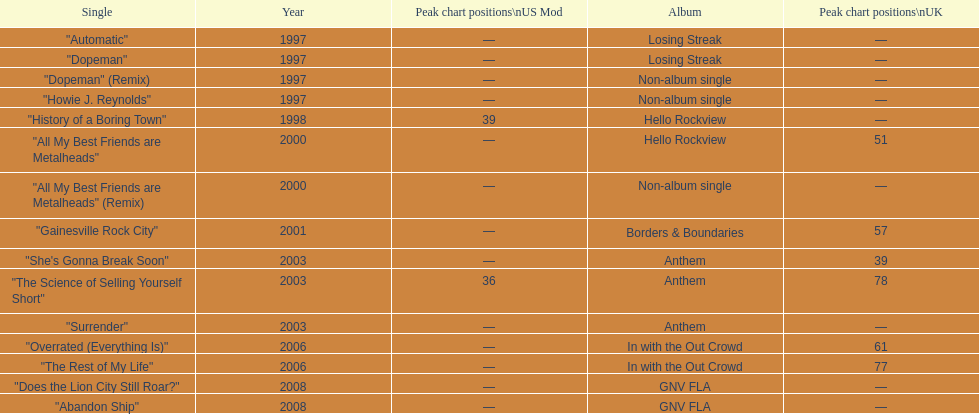Besides "dopeman", mention one more solitary tune present on the album "losing streak". "Automatic". Could you help me parse every detail presented in this table? {'header': ['Single', 'Year', 'Peak chart positions\\nUS Mod', 'Album', 'Peak chart positions\\nUK'], 'rows': [['"Automatic"', '1997', '—', 'Losing Streak', '—'], ['"Dopeman"', '1997', '—', 'Losing Streak', '—'], ['"Dopeman" (Remix)', '1997', '—', 'Non-album single', '—'], ['"Howie J. Reynolds"', '1997', '—', 'Non-album single', '—'], ['"History of a Boring Town"', '1998', '39', 'Hello Rockview', '—'], ['"All My Best Friends are Metalheads"', '2000', '—', 'Hello Rockview', '51'], ['"All My Best Friends are Metalheads" (Remix)', '2000', '—', 'Non-album single', '—'], ['"Gainesville Rock City"', '2001', '—', 'Borders & Boundaries', '57'], ['"She\'s Gonna Break Soon"', '2003', '—', 'Anthem', '39'], ['"The Science of Selling Yourself Short"', '2003', '36', 'Anthem', '78'], ['"Surrender"', '2003', '—', 'Anthem', '—'], ['"Overrated (Everything Is)"', '2006', '—', 'In with the Out Crowd', '61'], ['"The Rest of My Life"', '2006', '—', 'In with the Out Crowd', '77'], ['"Does the Lion City Still Roar?"', '2008', '—', 'GNV FLA', '—'], ['"Abandon Ship"', '2008', '—', 'GNV FLA', '—']]} 